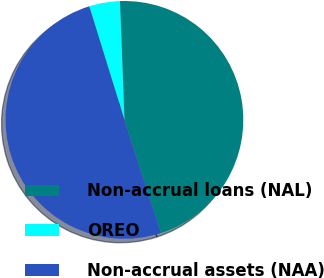<chart> <loc_0><loc_0><loc_500><loc_500><pie_chart><fcel>Non-accrual loans (NAL)<fcel>OREO<fcel>Non-accrual assets (NAA)<nl><fcel>45.63%<fcel>4.18%<fcel>50.19%<nl></chart> 